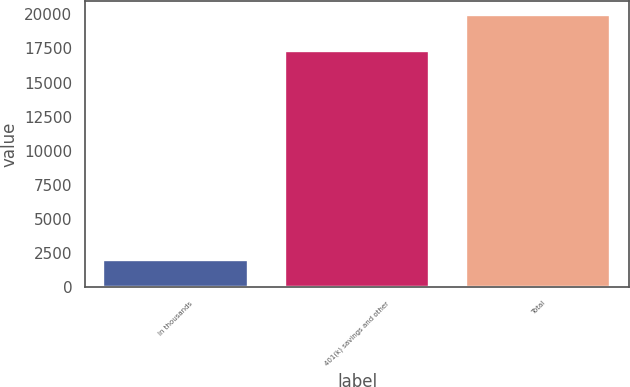<chart> <loc_0><loc_0><loc_500><loc_500><bar_chart><fcel>In thousands<fcel>401(k) savings and other<fcel>Total<nl><fcel>2013<fcel>17291<fcel>19969<nl></chart> 